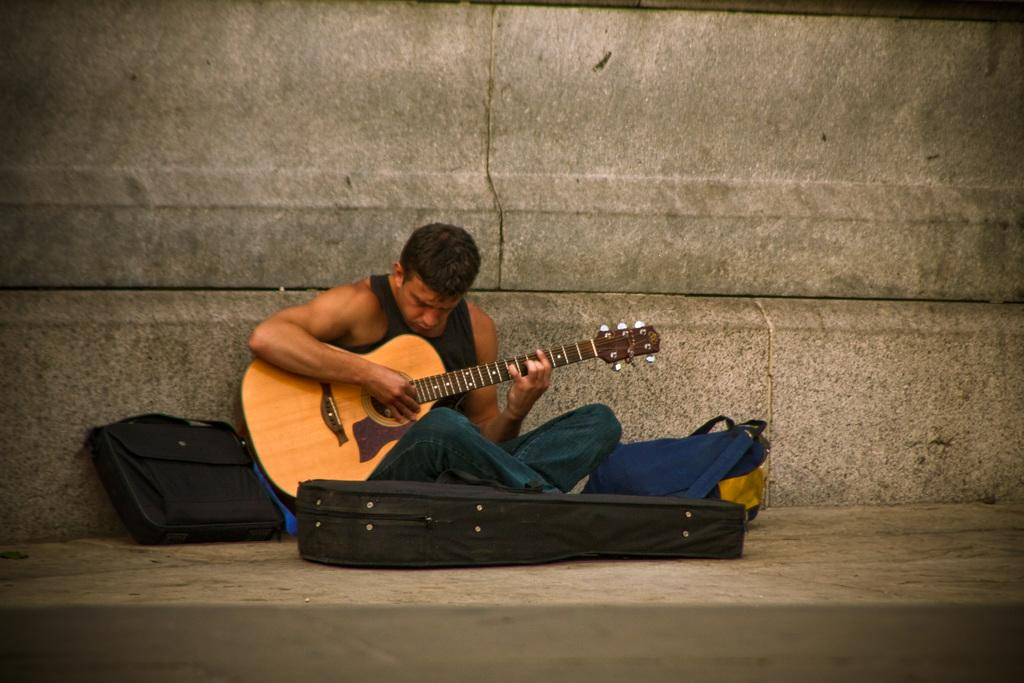Who is the main subject in the image? There is a man in the image. What is the man doing in the image? The man is sitting on the ground and playing the guitar. What is the man holding in the image? The man is holding a guitar. Are there any other objects in the image besides the man and the guitar? Yes, there are two bags in the image. What scientific experiment is the man conducting in the image? There is no scientific experiment being conducted in the image; the man is playing the guitar. How does the man get the attention of the viewers in the image? The man is not trying to get the attention of viewers in the image; he is simply playing the guitar. 